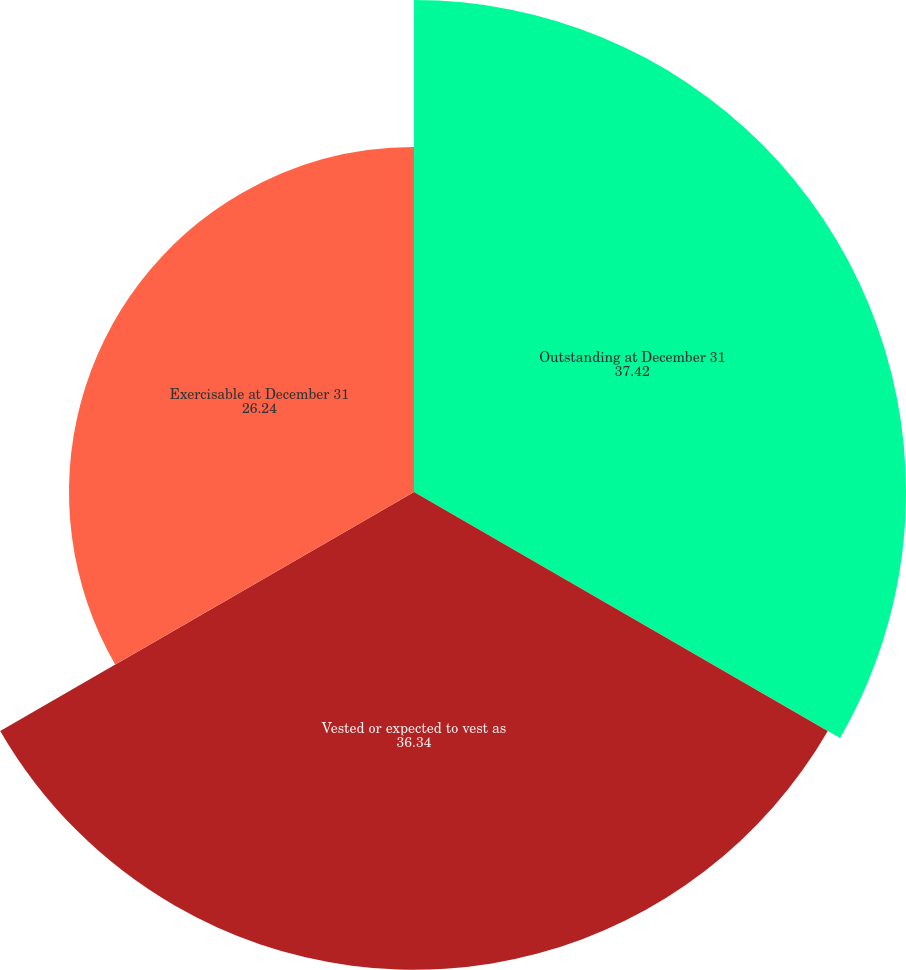Convert chart to OTSL. <chart><loc_0><loc_0><loc_500><loc_500><pie_chart><fcel>Outstanding at December 31<fcel>Vested or expected to vest as<fcel>Exercisable at December 31<nl><fcel>37.42%<fcel>36.34%<fcel>26.24%<nl></chart> 